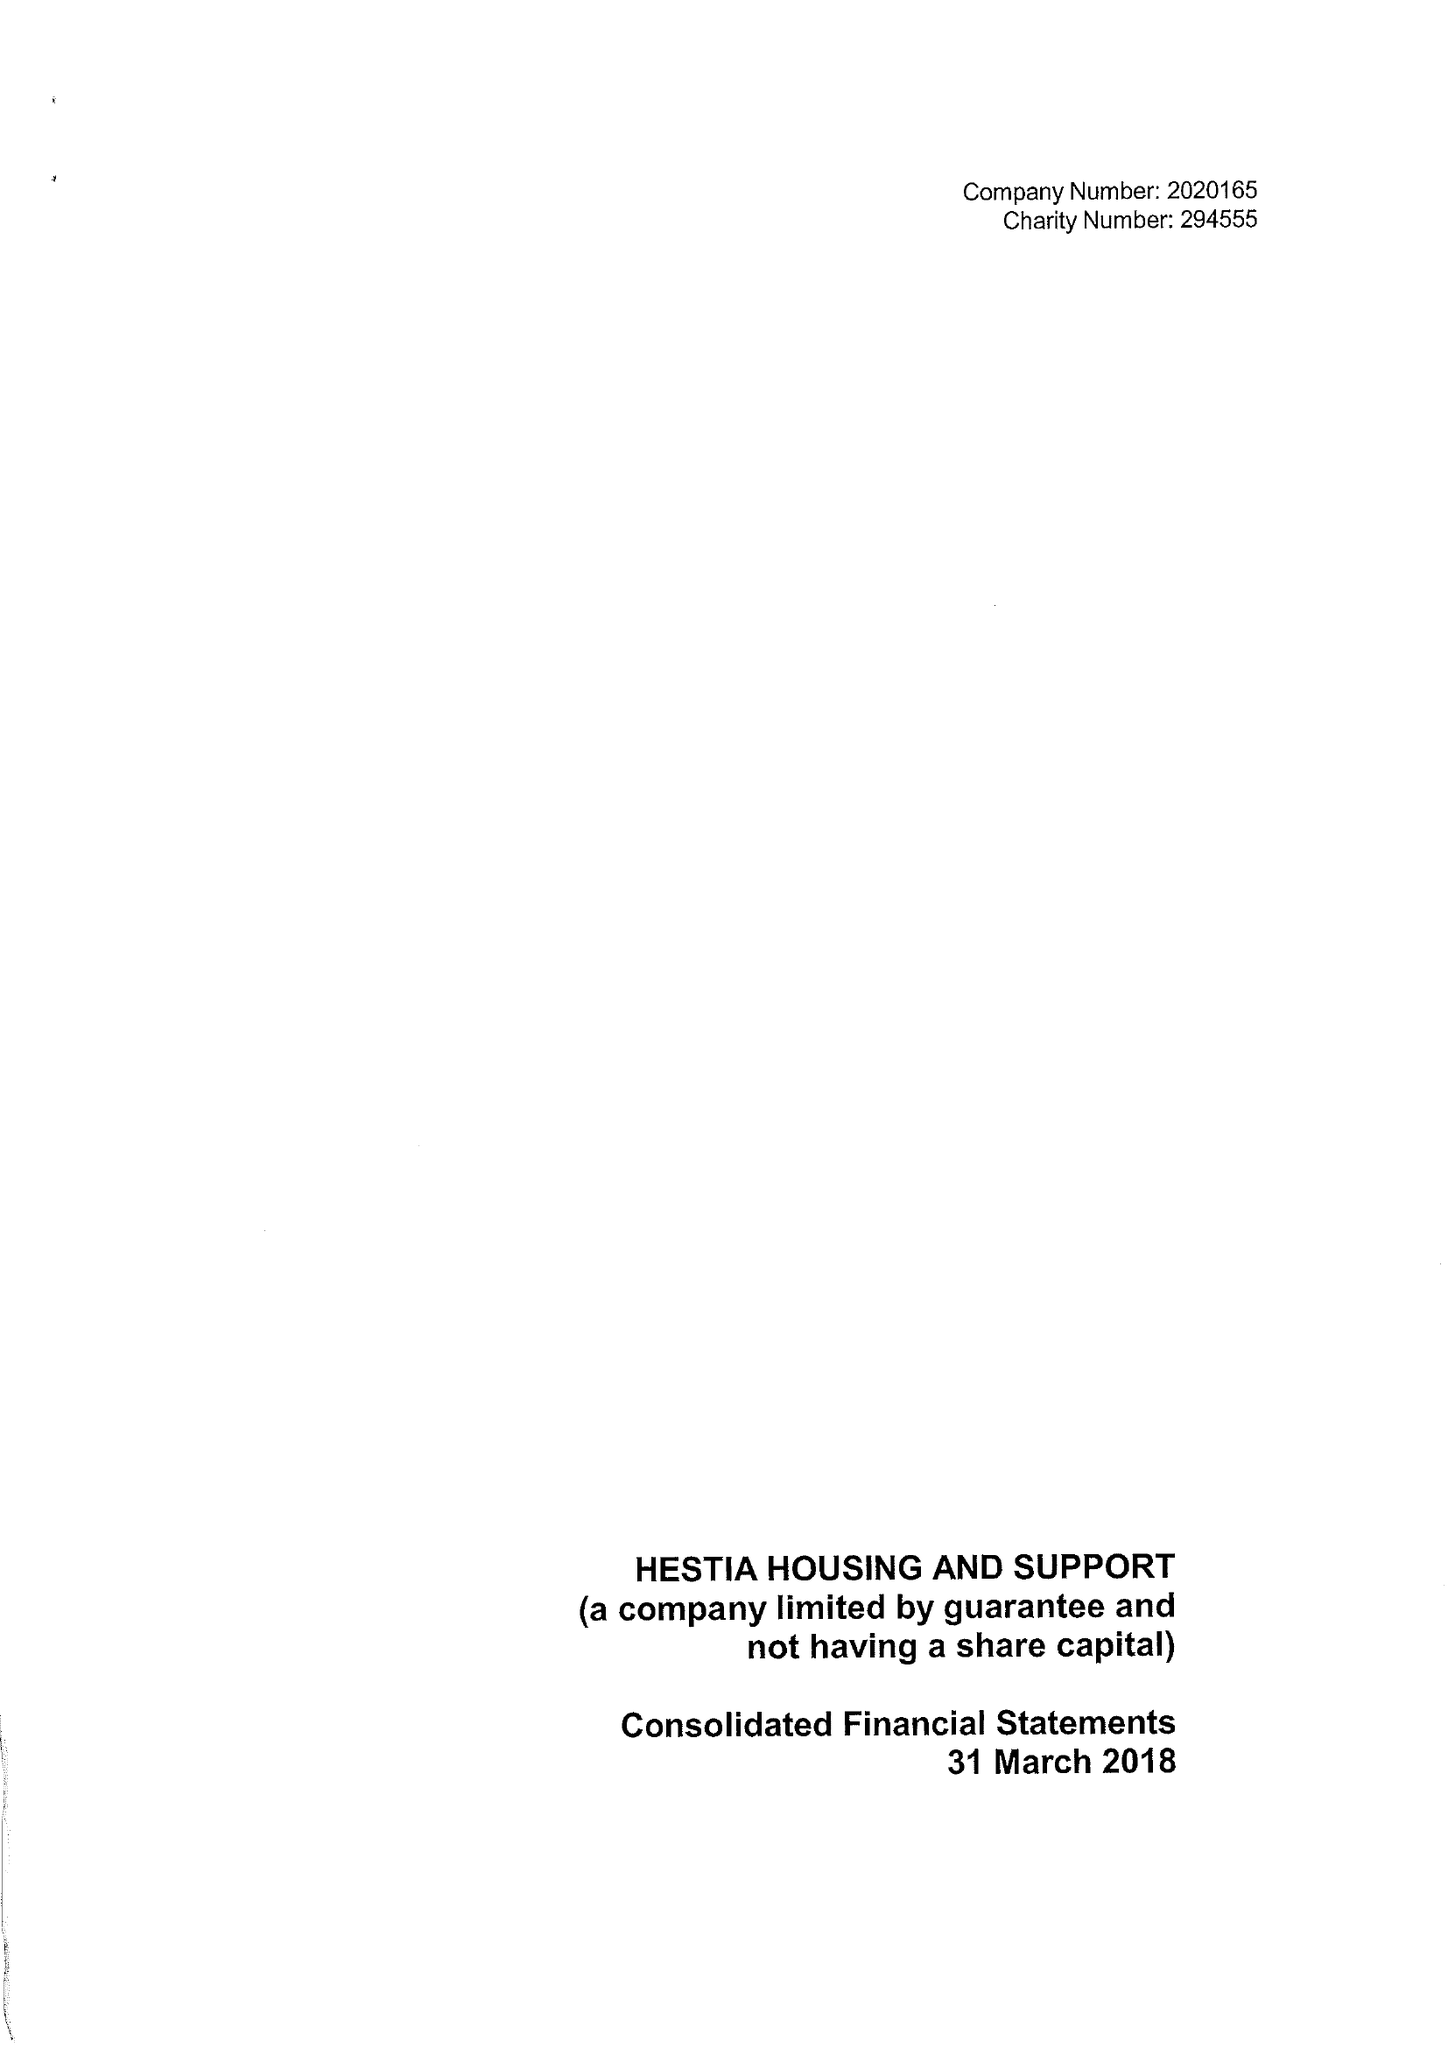What is the value for the charity_name?
Answer the question using a single word or phrase. Hestia Housing and Support 